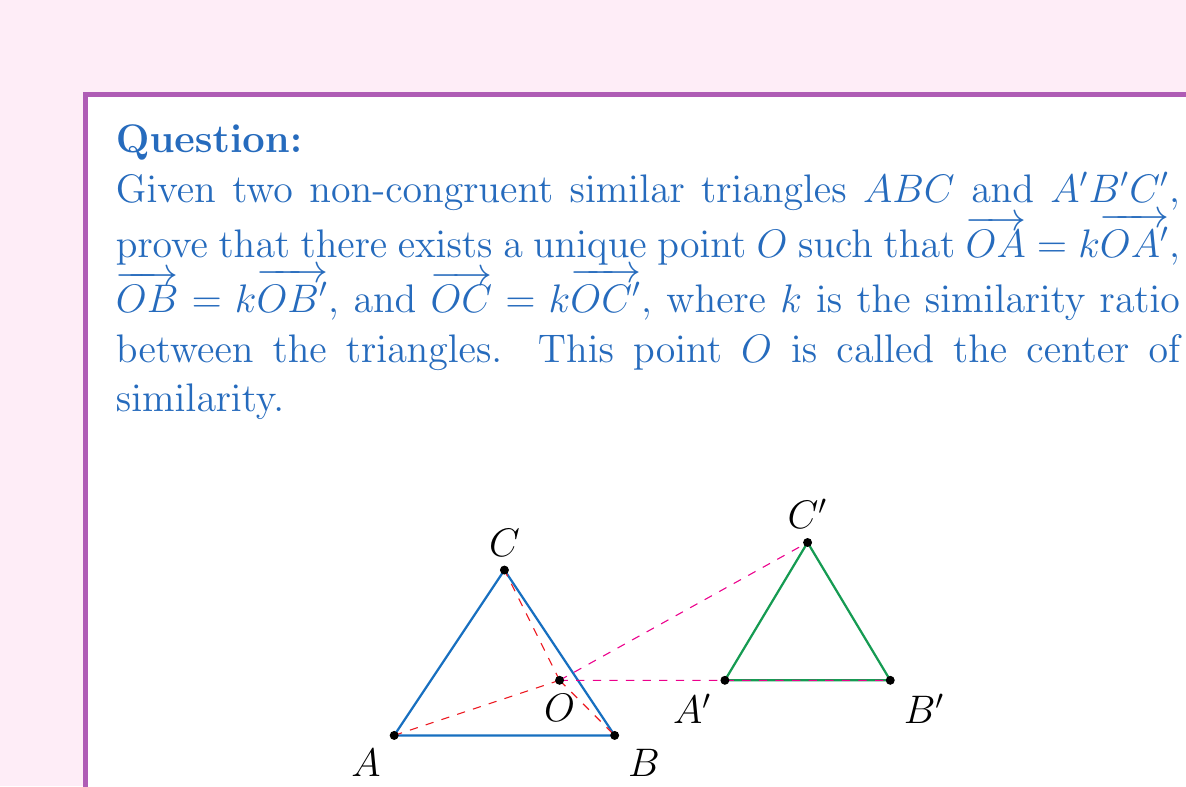Provide a solution to this math problem. To prove the existence and uniqueness of the center of similarity, we will follow these steps:

1) First, let's consider the line $AA'$. The center of similarity $O$ must lie on this line, as it divides $AA'$ in the ratio $k$.

2) Similarly, $O$ must lie on $BB'$ and $CC'$.

3) We need to prove that these three lines $AA'$, $BB'$, and $CC'$ intersect at a single point.

4) Let's assume that $AA'$ and $BB'$ intersect at point $O$. We need to prove that $CC'$ also passes through $O$.

5) Since $O$ is on $AA'$ and $BB'$, we have:

   $\overrightarrow{OA} = k\overrightarrow{OA'}$ and $\overrightarrow{OB} = k\overrightarrow{OB'}$

6) Subtracting these vector equations:

   $\overrightarrow{AB} = k\overrightarrow{A'B'}$

7) This proves that $O$ is indeed a center of similarity for points $A$, $B$, $A'$, and $B'$.

8) Now, let's consider point $C$. We can express $\overrightarrow{OC}$ as:

   $\overrightarrow{OC} = \overrightarrow{OA} + \overrightarrow{AC}$

9) Similarly for $C'$:

   $\overrightarrow{OC'} = \overrightarrow{OA'} + \overrightarrow{A'C'}$

10) We know that $\overrightarrow{AC} = k\overrightarrow{A'C'}$ (because the triangles are similar), and $\overrightarrow{OA} = k\overrightarrow{OA'}$ (from step 5).

11) Substituting these into the equation for $\overrightarrow{OC}$:

    $\overrightarrow{OC} = k\overrightarrow{OA'} + k\overrightarrow{A'C'} = k(\overrightarrow{OA'} + \overrightarrow{A'C'}) = k\overrightarrow{OC'}$

12) This proves that $O$ is also a center of similarity for point $C$, and therefore $CC'$ must pass through $O$.

13) Since all three lines $AA'$, $BB'$, and $CC'$ pass through $O$, we have proven the existence of a center of similarity.

14) The uniqueness follows from the fact that any point other than $O$ on $AA'$ would not satisfy the required ratio for $BB'$ and $CC'$.

Therefore, we have proven both the existence and uniqueness of the center of similarity for two non-congruent similar triangles.
Answer: The center of similarity exists and is unique, located at the intersection of $AA'$, $BB'$, and $CC'$. 